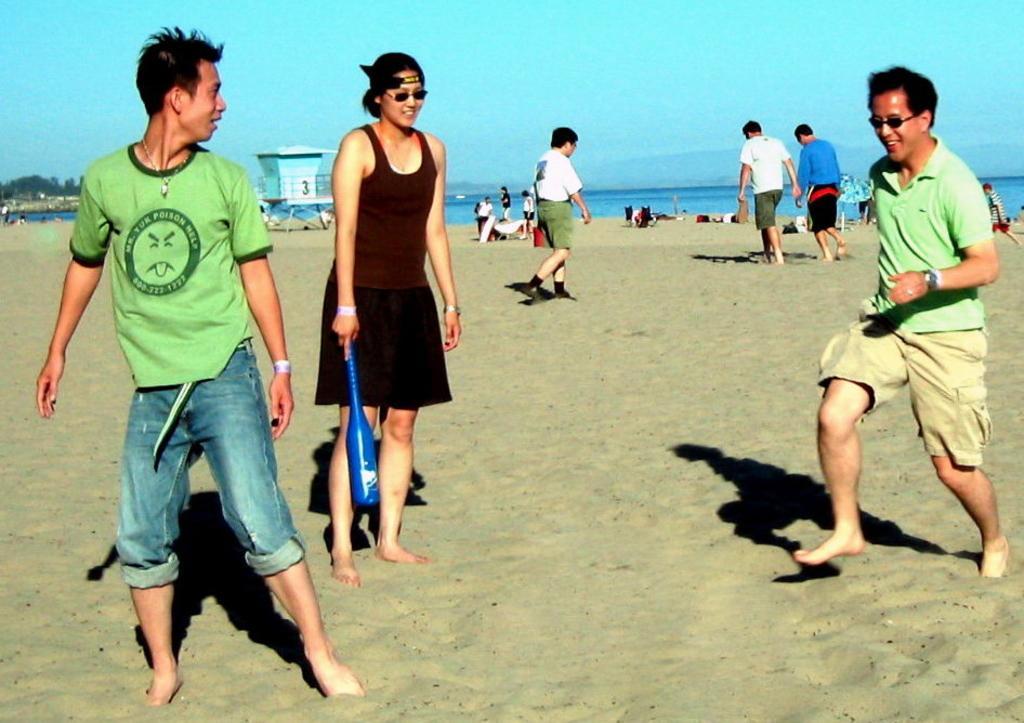Can you describe this image briefly? In this image we can see a group of people on the seashore. In that a woman is holding an object and a man is holding a skating board. On the backside we can see a house with a roof, a large water body, some trees, the hills and the sky. 